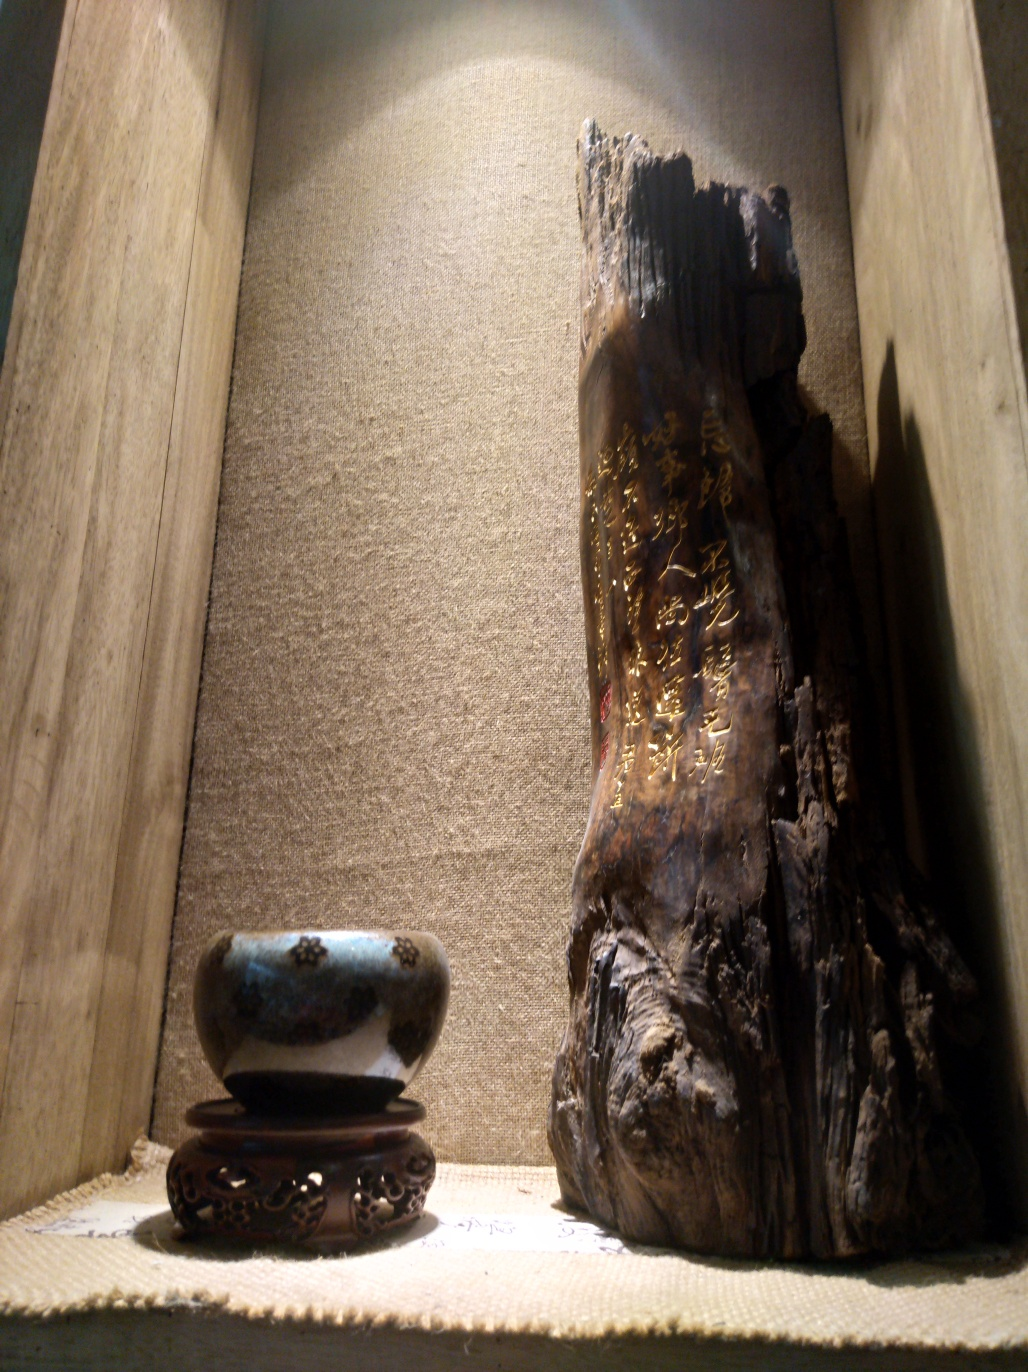What can you infer about the cultural significance of these items? The wooden carving bears golden characters that likely have some literary or historical significance, perhaps a poem or a proverb, indicating the item's cultural importance. It resembles an artifact that one would typically find in places of meditation or reverence. The ceramic bowl, while modest, is a utilitarian object that could be used in traditional customs or everyday life, suggesting a blend of artistry and practicality inherent to the culture it represents. Is there anything unusual or unique about the way these items are displayed? The display is unique as it places a common object, the bowl, on a pedestal, imbuing it with a sense of importance. It's juxtaposed with the wooden carving, which appears aged and significant. The backdrop and shelf materials also contribute to a rustic aesthetic that frames these items as timeless pieces connected to history and heritage. 